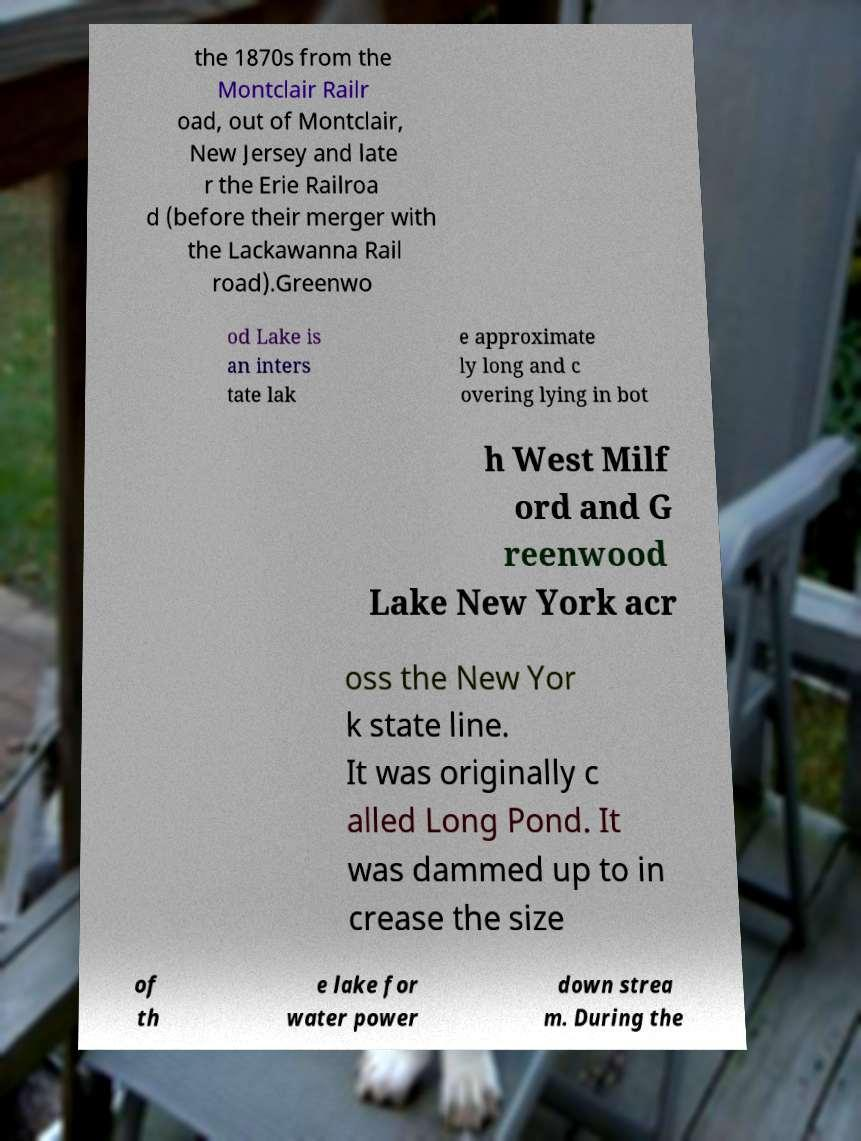Could you extract and type out the text from this image? the 1870s from the Montclair Railr oad, out of Montclair, New Jersey and late r the Erie Railroa d (before their merger with the Lackawanna Rail road).Greenwo od Lake is an inters tate lak e approximate ly long and c overing lying in bot h West Milf ord and G reenwood Lake New York acr oss the New Yor k state line. It was originally c alled Long Pond. It was dammed up to in crease the size of th e lake for water power down strea m. During the 